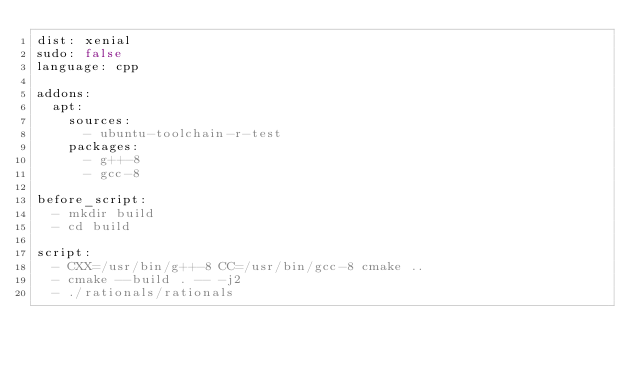<code> <loc_0><loc_0><loc_500><loc_500><_YAML_>dist: xenial
sudo: false
language: cpp

addons:
  apt:
    sources:
      - ubuntu-toolchain-r-test
    packages:
      - g++-8
      - gcc-8

before_script:
  - mkdir build
  - cd build

script:
  - CXX=/usr/bin/g++-8 CC=/usr/bin/gcc-8 cmake ..
  - cmake --build . -- -j2
  - ./rationals/rationals

</code> 